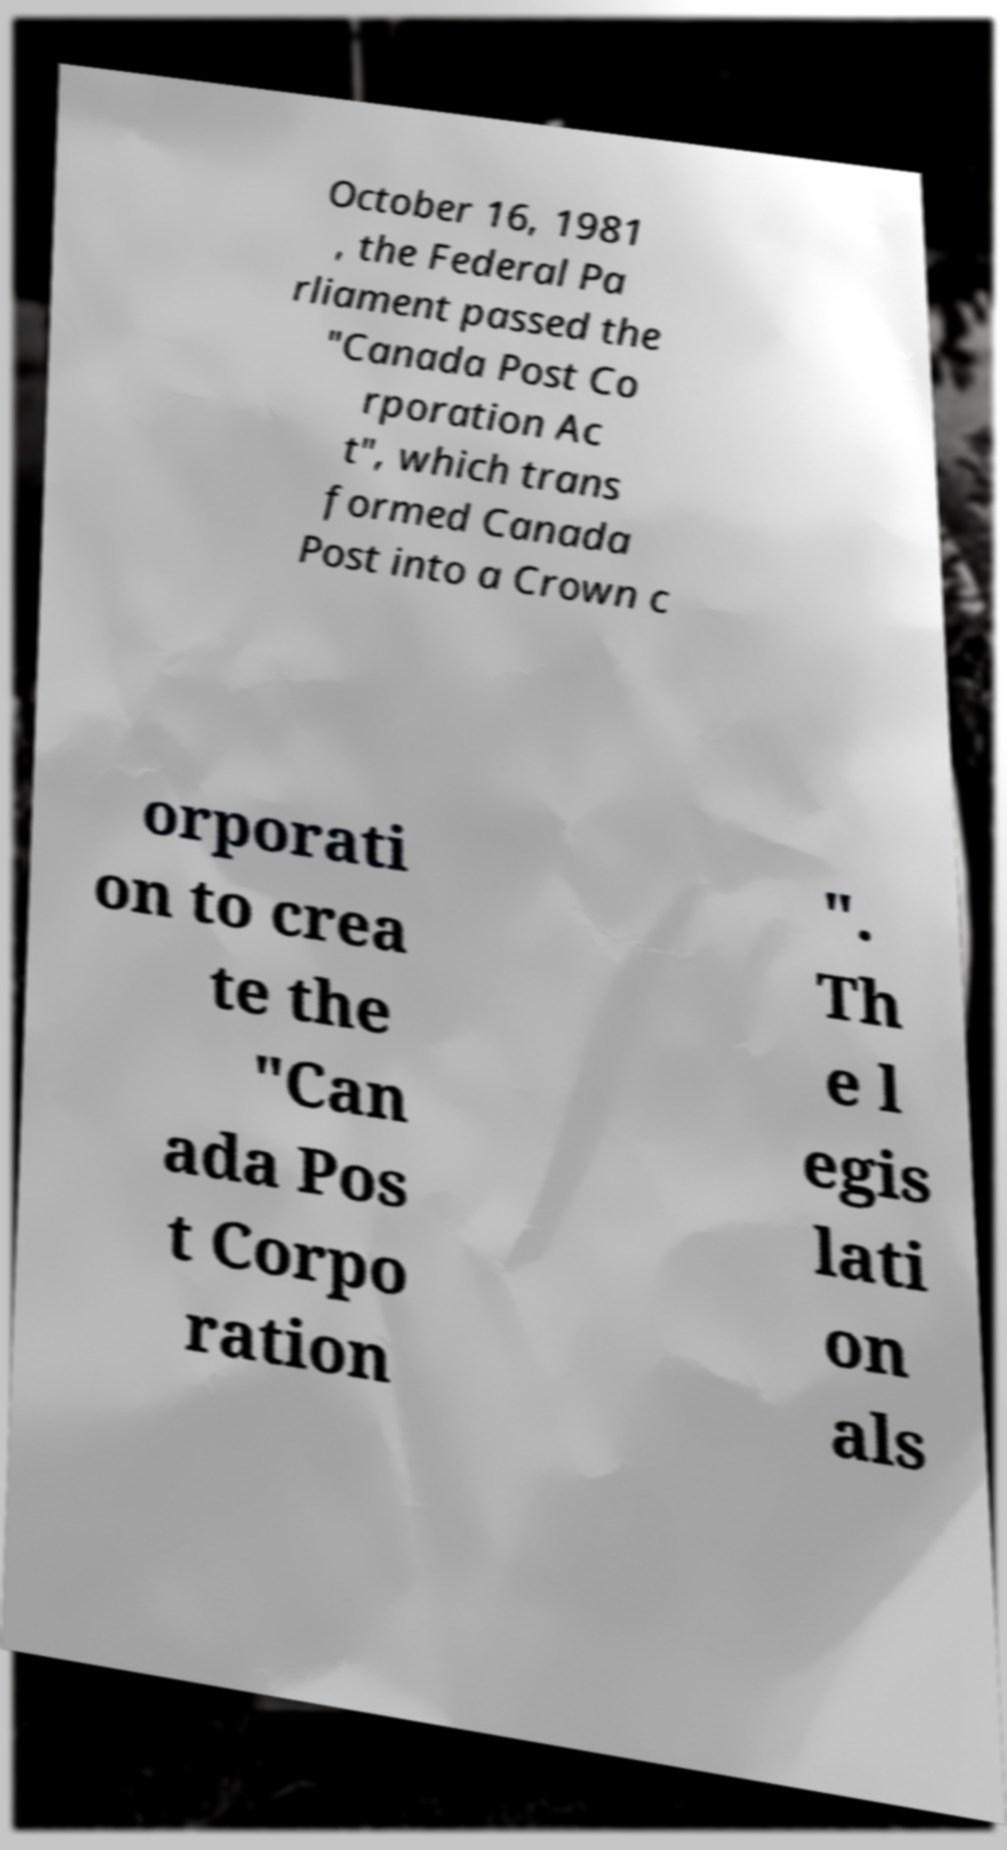What messages or text are displayed in this image? I need them in a readable, typed format. October 16, 1981 , the Federal Pa rliament passed the "Canada Post Co rporation Ac t", which trans formed Canada Post into a Crown c orporati on to crea te the "Can ada Pos t Corpo ration ". Th e l egis lati on als 